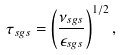<formula> <loc_0><loc_0><loc_500><loc_500>\tau _ { s g s } = \left ( \frac { \nu _ { s g s } } { \epsilon _ { s g s } } \right ) ^ { 1 / 2 } ,</formula> 